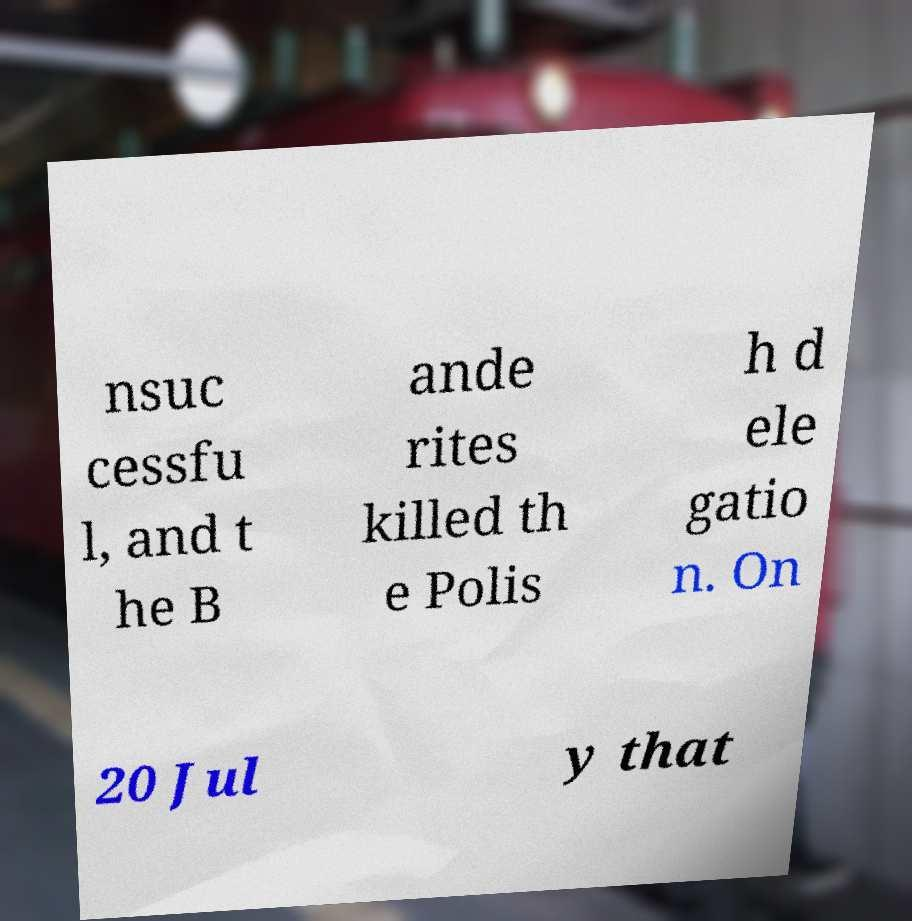Can you read and provide the text displayed in the image?This photo seems to have some interesting text. Can you extract and type it out for me? nsuc cessfu l, and t he B ande rites killed th e Polis h d ele gatio n. On 20 Jul y that 